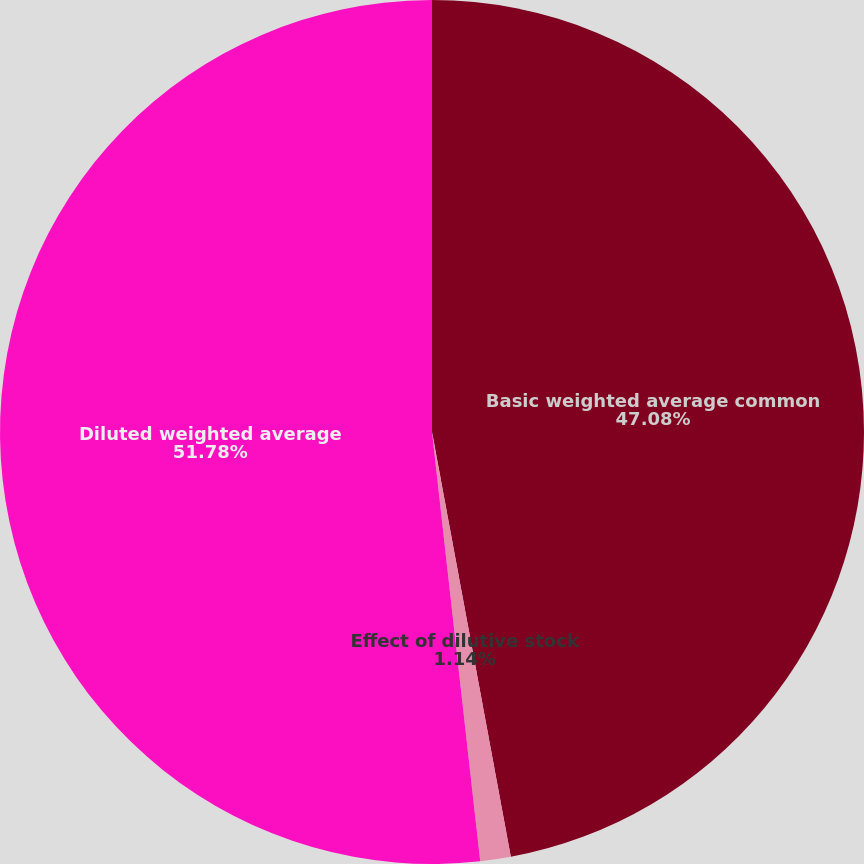Convert chart. <chart><loc_0><loc_0><loc_500><loc_500><pie_chart><fcel>Basic weighted average common<fcel>Effect of dilutive stock<fcel>Diluted weighted average<nl><fcel>47.08%<fcel>1.14%<fcel>51.78%<nl></chart> 